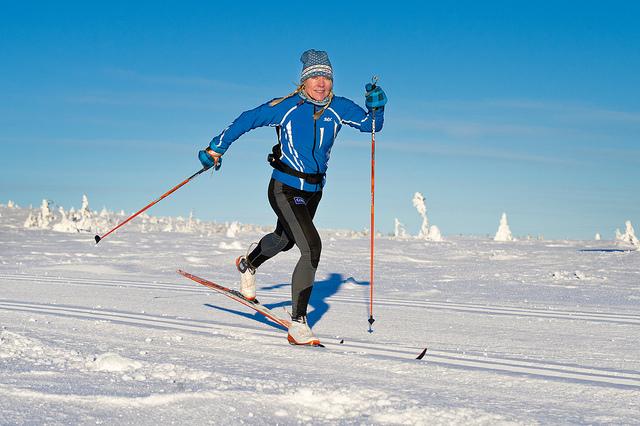Is the skier looking energetic?
Write a very short answer. Yes. What color is the persons coat?
Give a very brief answer. Blue. What is this person holding?
Write a very short answer. Ski poles. 